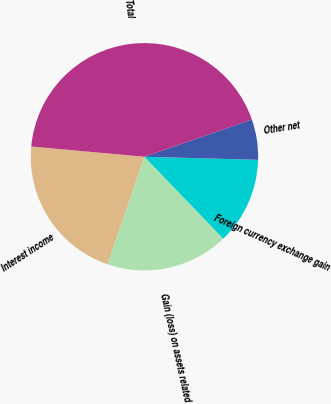Convert chart to OTSL. <chart><loc_0><loc_0><loc_500><loc_500><pie_chart><fcel>Interest income<fcel>Gain (loss) on assets related<fcel>Foreign currency exchange gain<fcel>Other net<fcel>Total<nl><fcel>21.19%<fcel>17.44%<fcel>12.38%<fcel>5.75%<fcel>43.24%<nl></chart> 